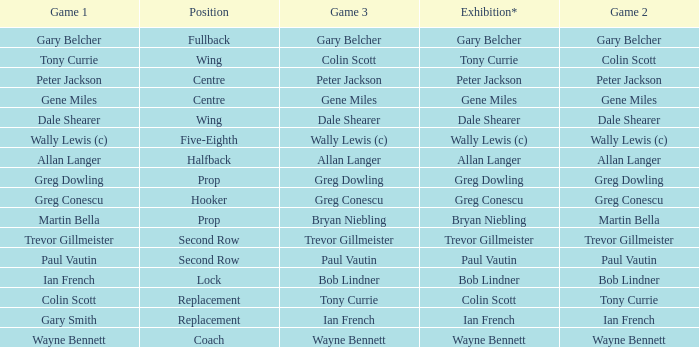Wjat game 3 has ian french as a game of 2? Ian French. 